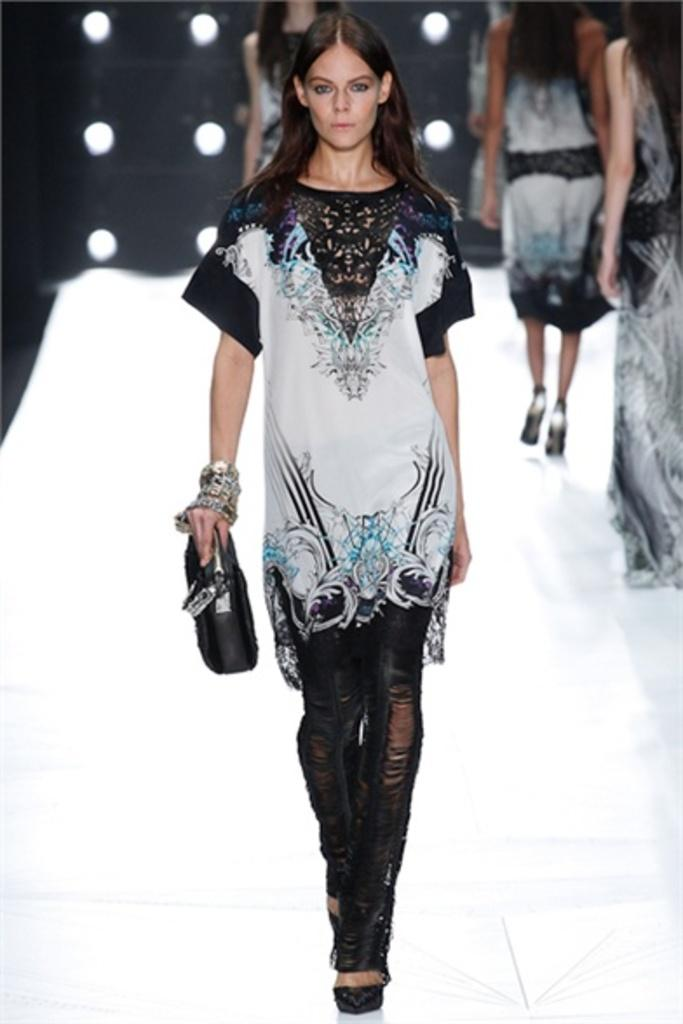What is the main subject of the image? There is a woman performing a ramp walk in the center of the image. What is the color of the floor in the image? The floor is white. Are there any other people visible in the image? Yes, there are a few women in the background of the image. What can be seen in the image that provides illumination? Lights are visible in the image. What type of oil can be seen dripping from the woman's shoes in the image? There is no oil or dripping visible on the woman's shoes in the image. What is the aftermath of the ramp walk in the image? The image captures the woman in the act of performing a ramp walk, so there is no aftermath visible. 